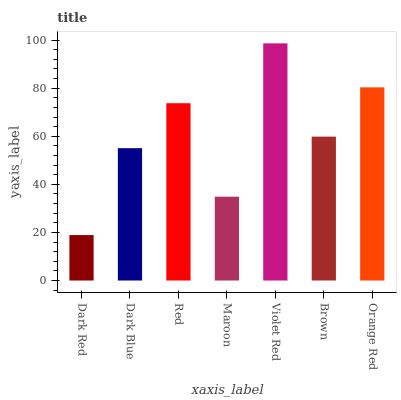Is Dark Red the minimum?
Answer yes or no. Yes. Is Violet Red the maximum?
Answer yes or no. Yes. Is Dark Blue the minimum?
Answer yes or no. No. Is Dark Blue the maximum?
Answer yes or no. No. Is Dark Blue greater than Dark Red?
Answer yes or no. Yes. Is Dark Red less than Dark Blue?
Answer yes or no. Yes. Is Dark Red greater than Dark Blue?
Answer yes or no. No. Is Dark Blue less than Dark Red?
Answer yes or no. No. Is Brown the high median?
Answer yes or no. Yes. Is Brown the low median?
Answer yes or no. Yes. Is Violet Red the high median?
Answer yes or no. No. Is Maroon the low median?
Answer yes or no. No. 